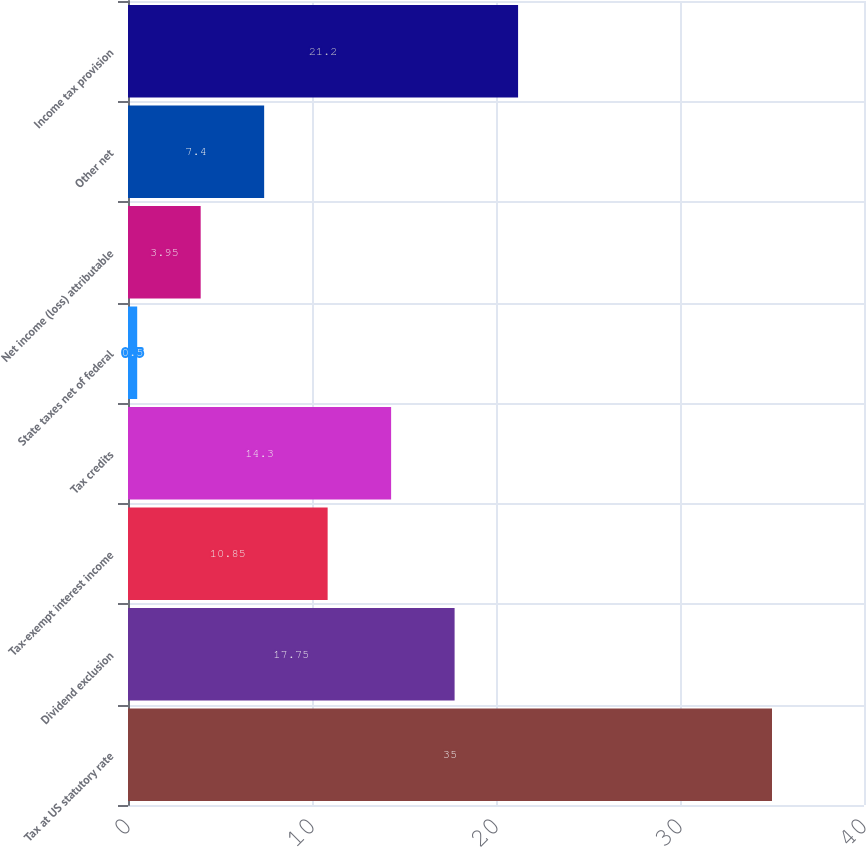Convert chart. <chart><loc_0><loc_0><loc_500><loc_500><bar_chart><fcel>Tax at US statutory rate<fcel>Dividend exclusion<fcel>Tax-exempt interest income<fcel>Tax credits<fcel>State taxes net of federal<fcel>Net income (loss) attributable<fcel>Other net<fcel>Income tax provision<nl><fcel>35<fcel>17.75<fcel>10.85<fcel>14.3<fcel>0.5<fcel>3.95<fcel>7.4<fcel>21.2<nl></chart> 